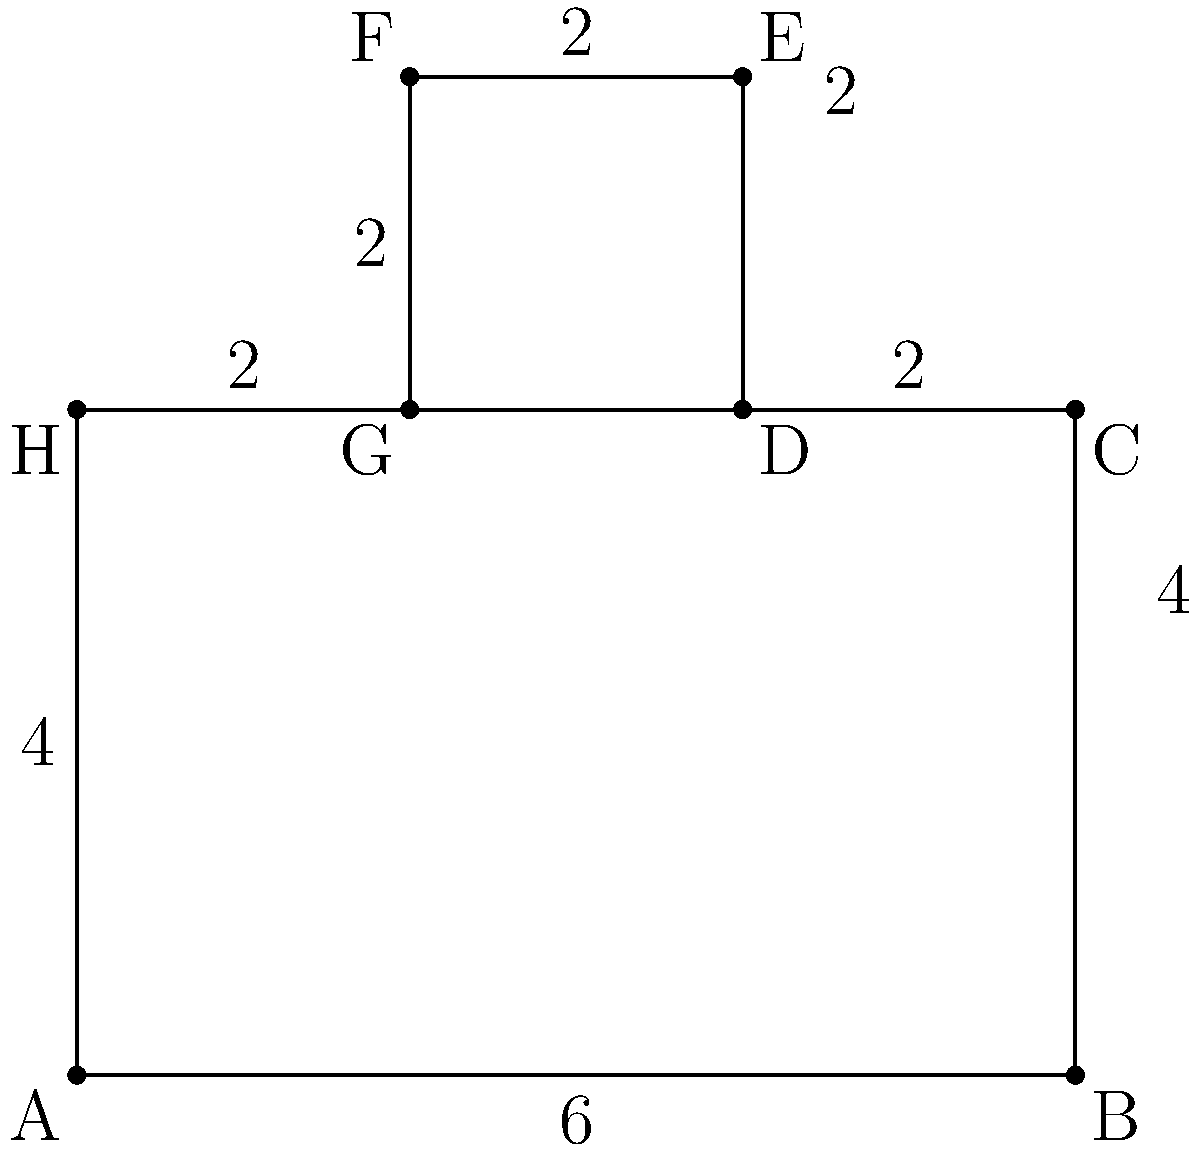As a software developer who values efficiency, you're tasked with optimizing a building's security system. The building's floor plan is represented by the given shape. Calculate the perimeter of this floor plan to determine the minimum length of security sensors needed for complete coverage. All measurements are in meters. Let's approach this systematically:

1) First, we'll identify the exterior edges of the shape:
   AB = 6m
   BC = 4m
   CD = 2m
   DE = 2m
   EF = 2m
   FG = 2m
   GH = 2m
   HA = 4m

2) Now, let's sum up these lengths:
   Perimeter = AB + BC + CD + DE + EF + FG + GH + HA
             = 6 + 4 + 2 + 2 + 2 + 2 + 2 + 4

3) Simplifying:
   Perimeter = 24m

4) To verify, we can group similar lengths:
   Perimeter = 6 + (4 * 2) + (2 * 5)
             = 6 + 8 + 10
             = 24m

Therefore, the perimeter of the floor plan is 24 meters.
Answer: 24m 